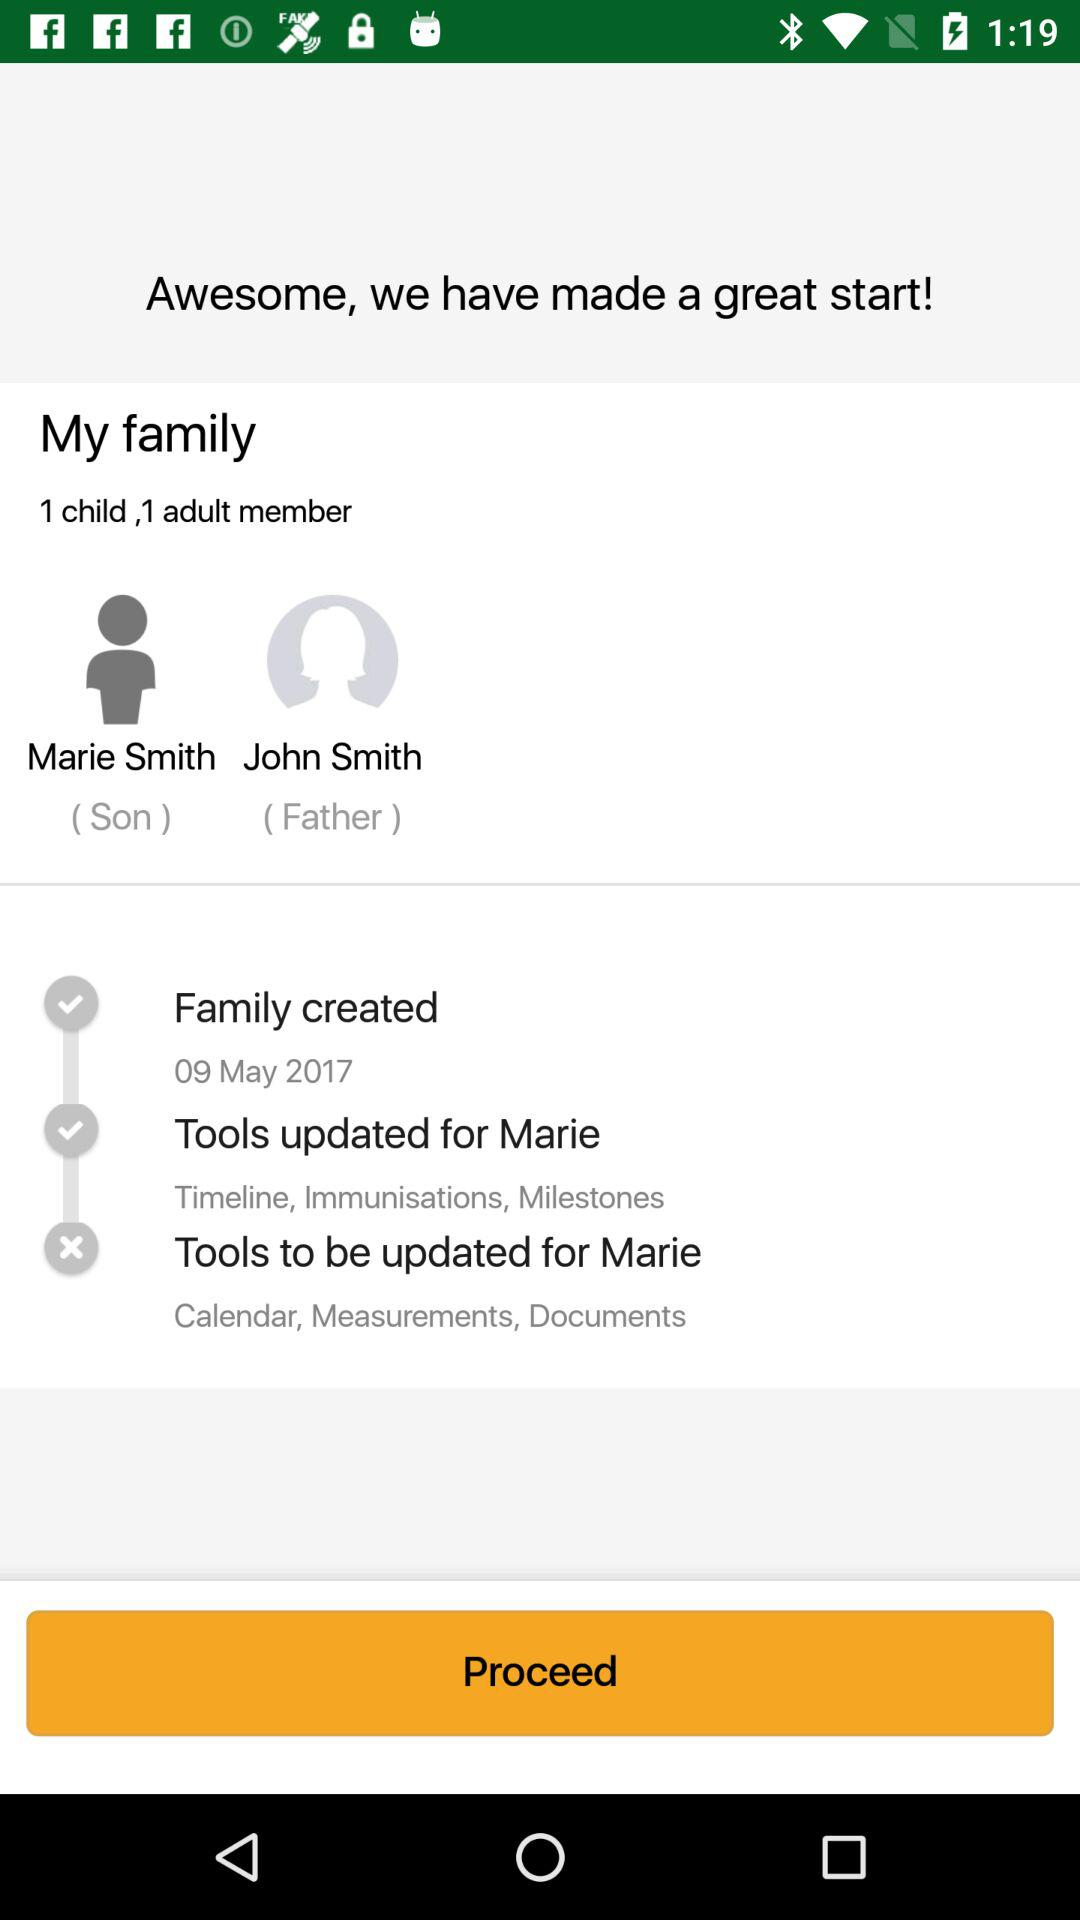What is the name of the son? The name of the son is Marie Smith. 